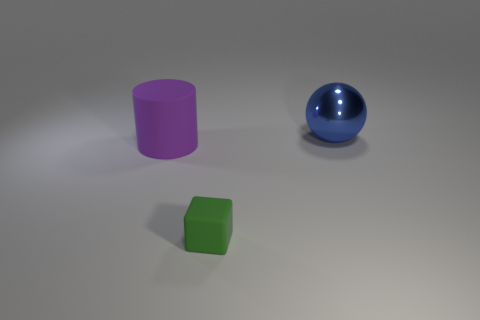What color is the ball?
Your response must be concise. Blue. What number of other large balls have the same color as the big metallic sphere?
Your response must be concise. 0. There is a large purple cylinder; are there any small rubber blocks behind it?
Offer a terse response. No. Is the number of large matte objects behind the blue metallic sphere the same as the number of large purple rubber things in front of the green matte cube?
Ensure brevity in your answer.  Yes. There is a object behind the big purple cylinder; is it the same size as the thing that is on the left side of the block?
Your answer should be compact. Yes. What shape is the object that is in front of the object that is left of the thing in front of the large rubber cylinder?
Keep it short and to the point. Cube. Is there any other thing that has the same material as the purple cylinder?
Give a very brief answer. Yes. The thing that is in front of the big metal ball and on the right side of the purple cylinder is what color?
Provide a short and direct response. Green. Is the material of the big cylinder the same as the large thing that is on the right side of the green matte thing?
Ensure brevity in your answer.  No. Is the number of green objects behind the big purple matte cylinder less than the number of purple rubber objects?
Your response must be concise. Yes. 